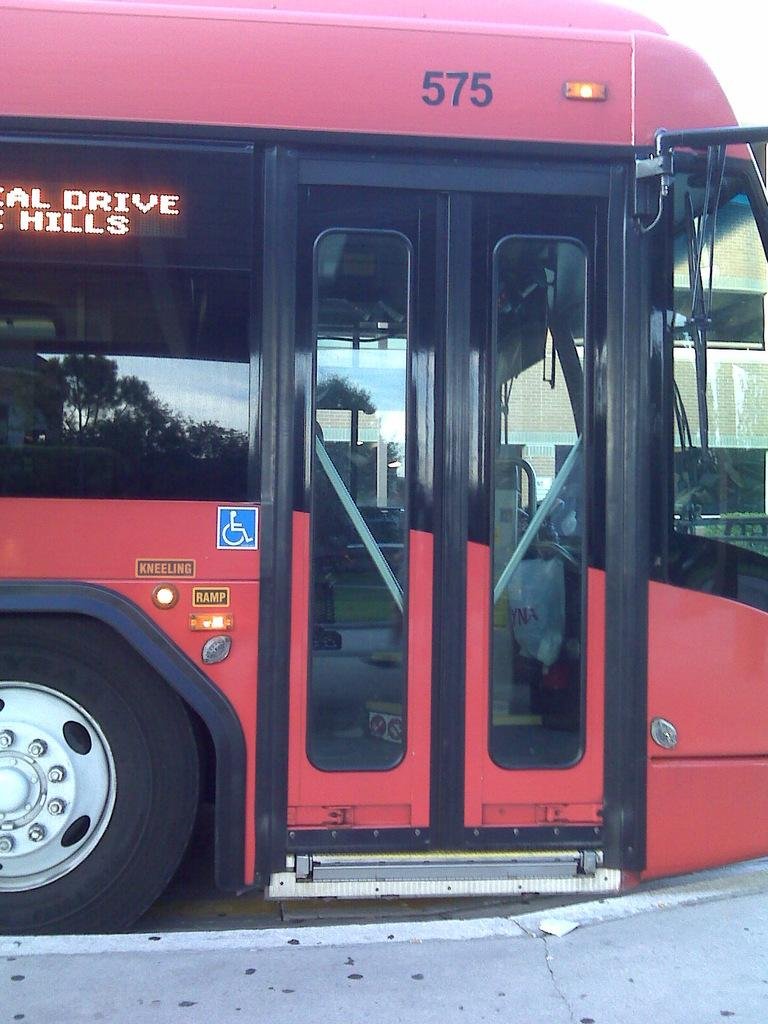What type of vehicle is in the picture? There is a red color bus in the picture. What feature does the bus have on its front? The bus has a LED display. How would you describe the sky in the picture? The sky is cloudy in the picture. What is the tendency of the wrist in the image? There is no wrist visible in the image, as it features a bus with a LED display and a cloudy sky. 